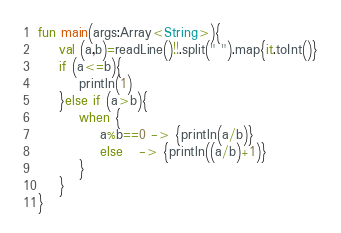<code> <loc_0><loc_0><loc_500><loc_500><_Kotlin_>fun main(args:Array<String>){
    val (a,b)=readLine()!!.split(" ").map{it.toInt()}
    if (a<=b){
        println(1)
    }else if (a>b){
        when {
            a%b==0 -> {println(a/b)}
            else   -> {println((a/b)+1)}
        }
    }
}</code> 